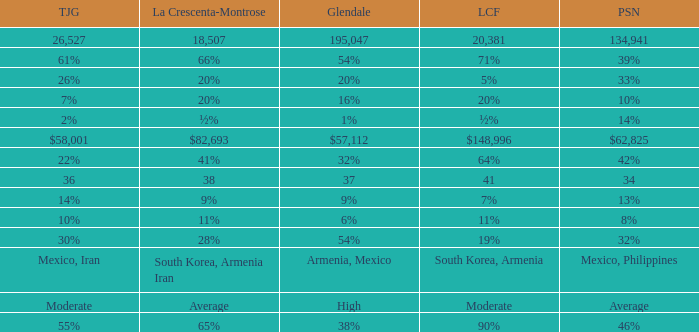What is the figure for La Crescenta-Montrose when Gelndale is $57,112? $82,693. 